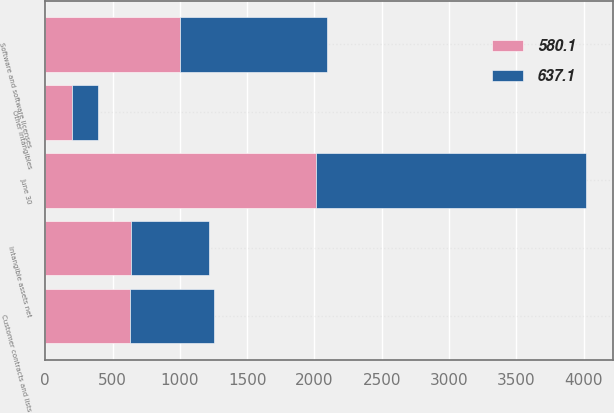Convert chart. <chart><loc_0><loc_0><loc_500><loc_500><stacked_bar_chart><ecel><fcel>June 30<fcel>Software and software licenses<fcel>Customer contracts and lists<fcel>Other intangibles<fcel>Intangible assets net<nl><fcel>637.1<fcel>2009<fcel>1085.2<fcel>623.1<fcel>197.3<fcel>580.1<nl><fcel>580.1<fcel>2008<fcel>1004.5<fcel>627<fcel>197.2<fcel>637.1<nl></chart> 